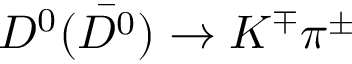Convert formula to latex. <formula><loc_0><loc_0><loc_500><loc_500>D ^ { 0 } ( \bar { D ^ { 0 } } ) \rightarrow K ^ { \mp } \pi ^ { \pm }</formula> 